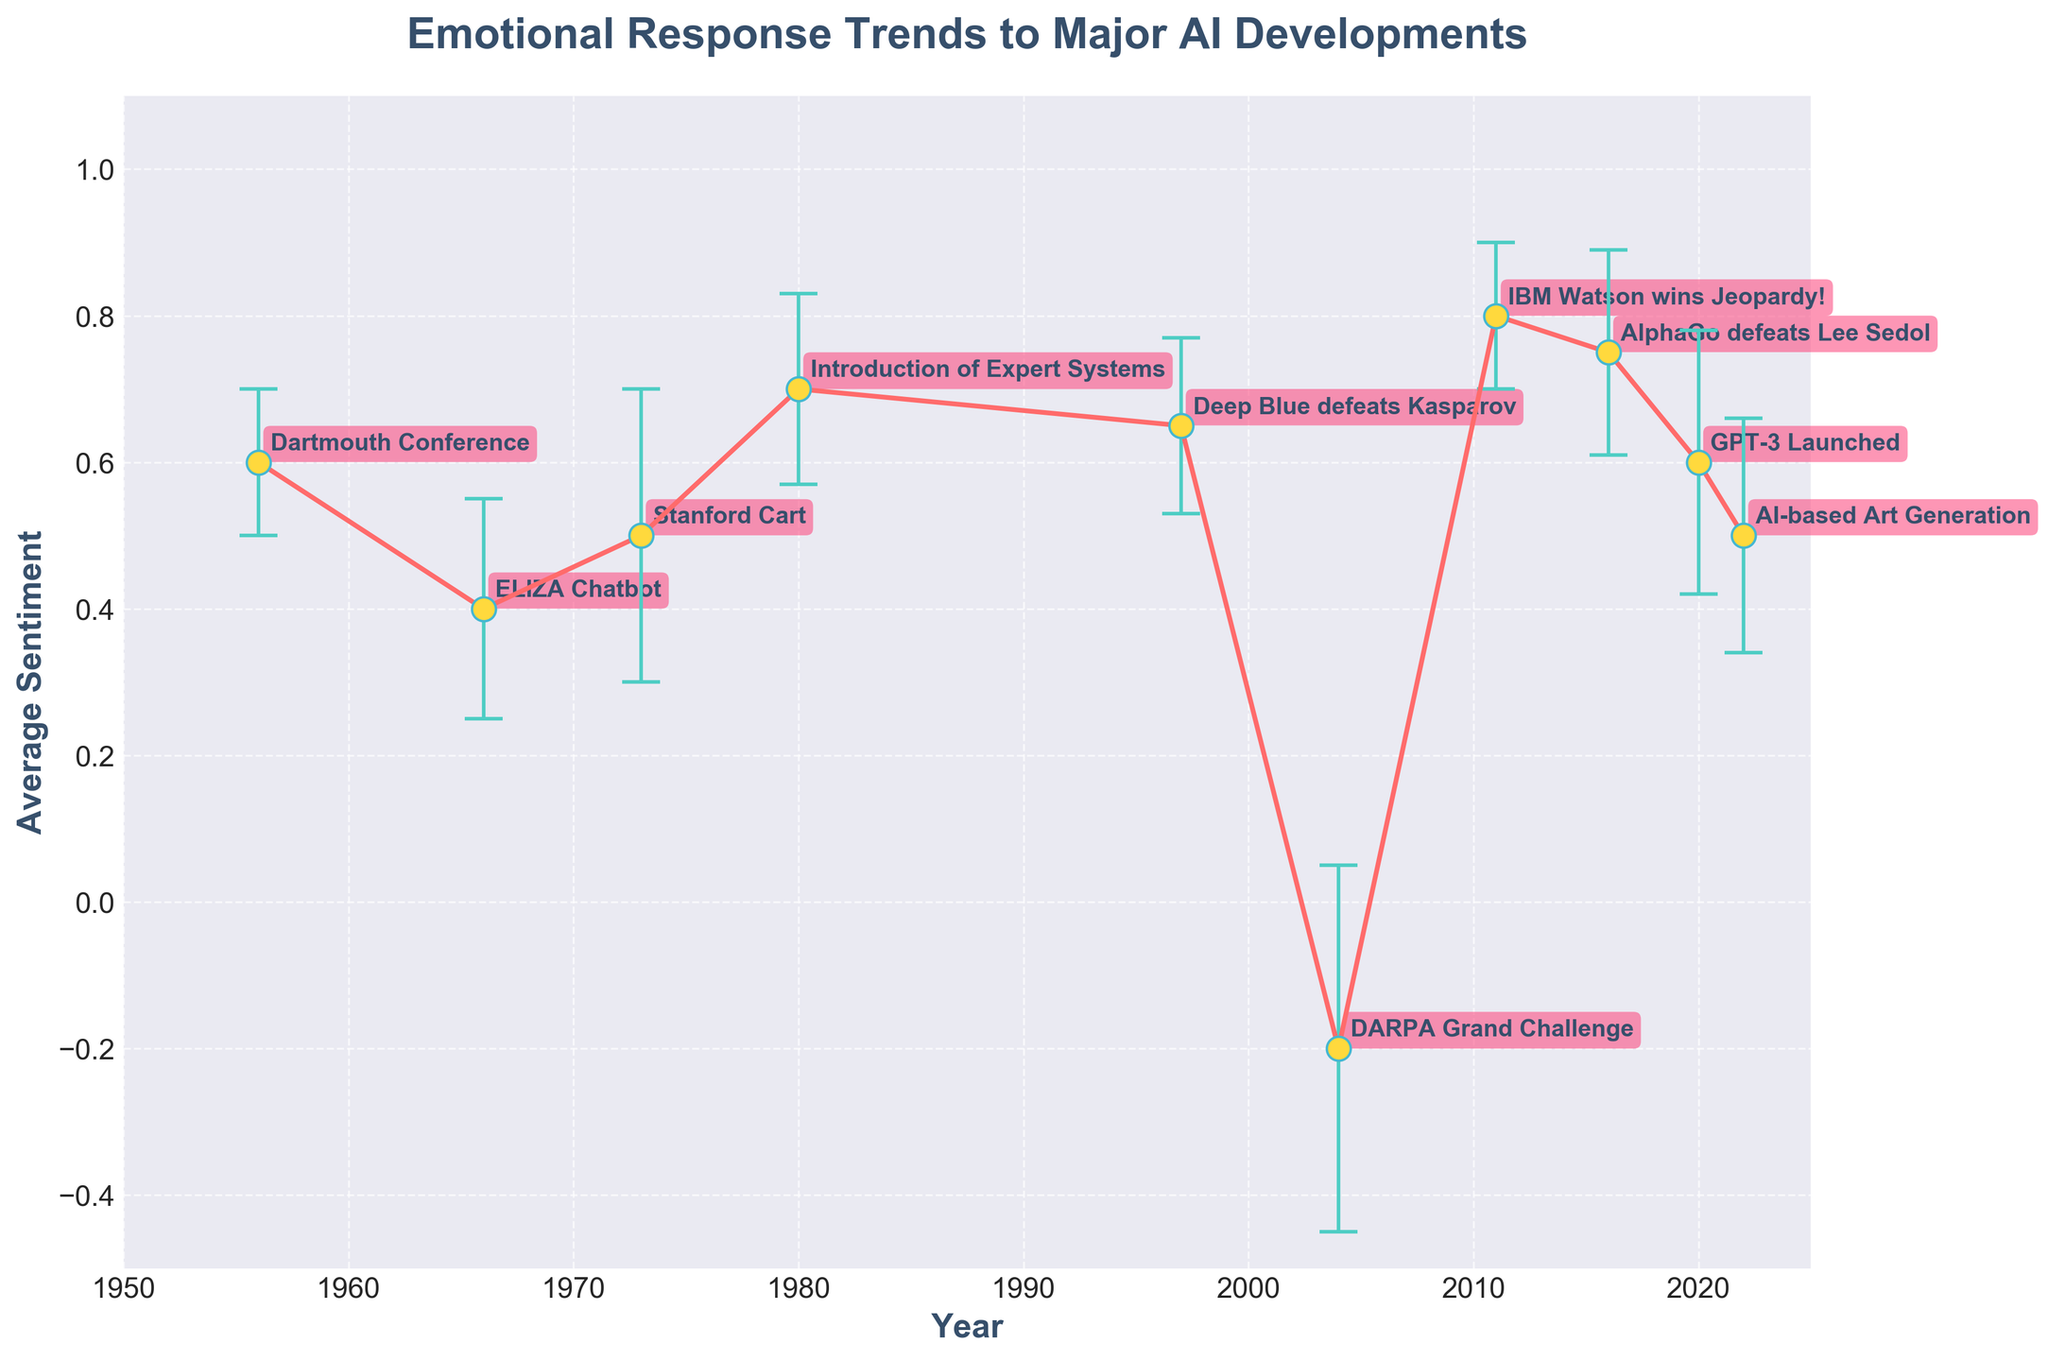What is the title of the plot? The title of the plot is at the top in larger, bold font, providing an overview of what the plot represents.
Answer: Emotional Response Trends to Major AI Developments How many AI developments are represented in the plot? Count the number of unique markers, each labeled with an AI development.
Answer: 10 Which AI development in the plot has the highest average sentiment? Look at the data points and identify the one with the highest y-position.
Answer: IBM Watson wins Jeopardy! Which development has the lowest average sentiment and what is its value? Identify the data point with the lowest y-position and read its value.
Answer: DARPA Grand Challenge, -0.2 What is the average sentiment value for the Stanford Cart development? Find the 'Stanford Cart' label on the x-axis and check its corresponding y-position value.
Answer: 0.5 Which years exhibited sentiment values above 0.7? Identify data points where the y-position is greater than 0.7 and note their respective years.
Answer: 1980, 2011 Calculate the range of the average sentiments observed in the plot. Subtract the minimum average sentiment value from the maximum average sentiment value.
Answer: 1.0 What is the sentiment deviation range for the development with the largest standard deviation? Identify the largest standard deviation from the error bars and add and subtract this value from its average sentiment.
Answer: DARPA Grand Challenge, -0.45 to 0.05 Between which two successive AI developments is there the greatest increase in sentiment? Compute the differences in average sentiment between each successive pair of developments and identify the largest positive difference.
Answer: Introduction of Expert Systems (1980) to Deep Blue defeats Kasparov (1997) Which development has a sentiment fluctuation range that crosses from positive to negative? Look for error bars that extend from above zero to below zero sentiment values.
Answer: DARPA Grand Challenge 